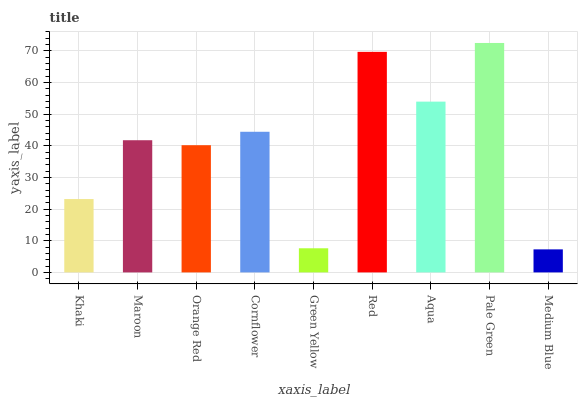Is Medium Blue the minimum?
Answer yes or no. Yes. Is Pale Green the maximum?
Answer yes or no. Yes. Is Maroon the minimum?
Answer yes or no. No. Is Maroon the maximum?
Answer yes or no. No. Is Maroon greater than Khaki?
Answer yes or no. Yes. Is Khaki less than Maroon?
Answer yes or no. Yes. Is Khaki greater than Maroon?
Answer yes or no. No. Is Maroon less than Khaki?
Answer yes or no. No. Is Maroon the high median?
Answer yes or no. Yes. Is Maroon the low median?
Answer yes or no. Yes. Is Cornflower the high median?
Answer yes or no. No. Is Khaki the low median?
Answer yes or no. No. 